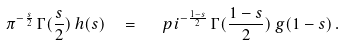Convert formula to latex. <formula><loc_0><loc_0><loc_500><loc_500>\pi ^ { - \frac { s } { 2 } } \, \Gamma ( { \frac { s } { 2 } } ) \, h ( s ) \ \ = \ \ \ p i ^ { - \frac { 1 - s } { 2 } } \, \Gamma ( { \frac { 1 - s } { 2 } } ) \, g ( 1 - s ) \, .</formula> 